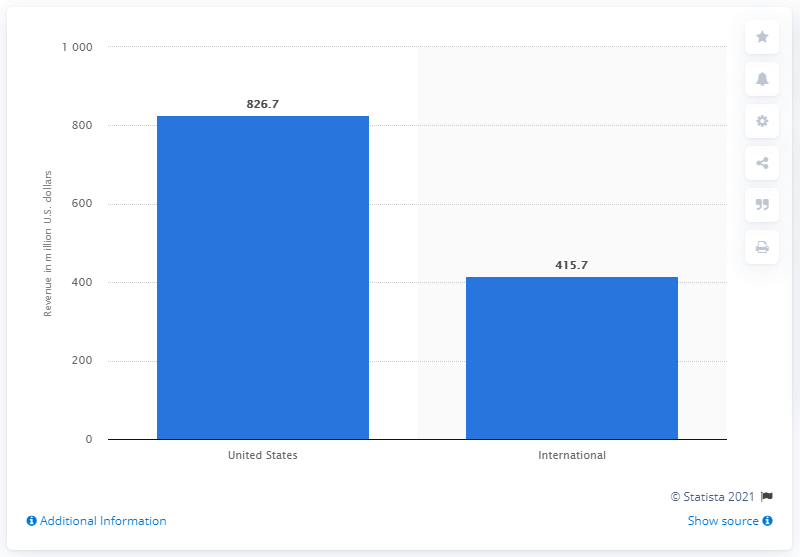List a handful of essential elements in this visual. In 2020, the domestic revenue for AMC Theatres was $826.7 million. In 2019, AMC generated a total of 826.7 million U.S. dollars in domestic revenue. 